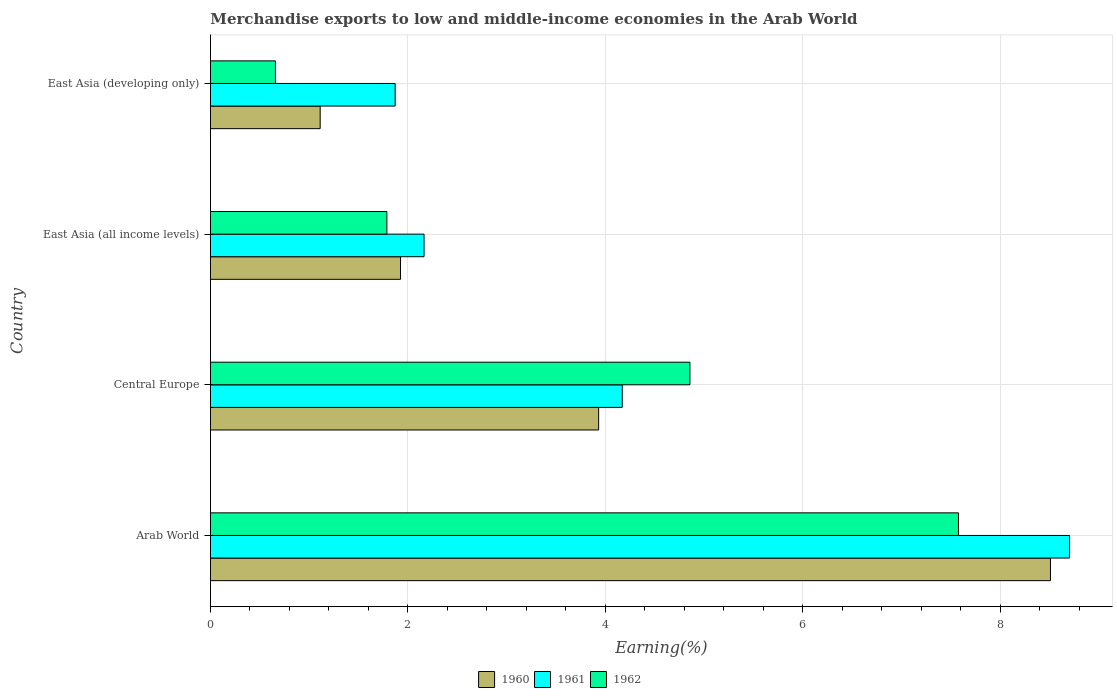How many groups of bars are there?
Your answer should be compact. 4. What is the label of the 3rd group of bars from the top?
Make the answer very short. Central Europe. In how many cases, is the number of bars for a given country not equal to the number of legend labels?
Offer a very short reply. 0. What is the percentage of amount earned from merchandise exports in 1960 in Arab World?
Keep it short and to the point. 8.51. Across all countries, what is the maximum percentage of amount earned from merchandise exports in 1960?
Keep it short and to the point. 8.51. Across all countries, what is the minimum percentage of amount earned from merchandise exports in 1960?
Offer a very short reply. 1.11. In which country was the percentage of amount earned from merchandise exports in 1961 maximum?
Provide a succinct answer. Arab World. In which country was the percentage of amount earned from merchandise exports in 1961 minimum?
Make the answer very short. East Asia (developing only). What is the total percentage of amount earned from merchandise exports in 1961 in the graph?
Offer a terse response. 16.91. What is the difference between the percentage of amount earned from merchandise exports in 1962 in Arab World and that in East Asia (developing only)?
Your answer should be compact. 6.92. What is the difference between the percentage of amount earned from merchandise exports in 1960 in Arab World and the percentage of amount earned from merchandise exports in 1961 in East Asia (developing only)?
Provide a short and direct response. 6.64. What is the average percentage of amount earned from merchandise exports in 1961 per country?
Give a very brief answer. 4.23. What is the difference between the percentage of amount earned from merchandise exports in 1960 and percentage of amount earned from merchandise exports in 1962 in East Asia (all income levels)?
Offer a terse response. 0.14. In how many countries, is the percentage of amount earned from merchandise exports in 1960 greater than 3.6 %?
Keep it short and to the point. 2. What is the ratio of the percentage of amount earned from merchandise exports in 1960 in East Asia (all income levels) to that in East Asia (developing only)?
Your answer should be very brief. 1.73. Is the difference between the percentage of amount earned from merchandise exports in 1960 in Arab World and East Asia (all income levels) greater than the difference between the percentage of amount earned from merchandise exports in 1962 in Arab World and East Asia (all income levels)?
Offer a very short reply. Yes. What is the difference between the highest and the second highest percentage of amount earned from merchandise exports in 1960?
Make the answer very short. 4.58. What is the difference between the highest and the lowest percentage of amount earned from merchandise exports in 1960?
Your response must be concise. 7.4. What does the 3rd bar from the top in Central Europe represents?
Ensure brevity in your answer.  1960. Is it the case that in every country, the sum of the percentage of amount earned from merchandise exports in 1962 and percentage of amount earned from merchandise exports in 1960 is greater than the percentage of amount earned from merchandise exports in 1961?
Provide a short and direct response. No. Are the values on the major ticks of X-axis written in scientific E-notation?
Your answer should be very brief. No. Does the graph contain grids?
Offer a terse response. Yes. What is the title of the graph?
Provide a succinct answer. Merchandise exports to low and middle-income economies in the Arab World. Does "1997" appear as one of the legend labels in the graph?
Your response must be concise. No. What is the label or title of the X-axis?
Ensure brevity in your answer.  Earning(%). What is the Earning(%) of 1960 in Arab World?
Provide a succinct answer. 8.51. What is the Earning(%) of 1961 in Arab World?
Offer a terse response. 8.7. What is the Earning(%) in 1962 in Arab World?
Keep it short and to the point. 7.58. What is the Earning(%) in 1960 in Central Europe?
Your answer should be compact. 3.93. What is the Earning(%) of 1961 in Central Europe?
Offer a terse response. 4.17. What is the Earning(%) of 1962 in Central Europe?
Make the answer very short. 4.86. What is the Earning(%) in 1960 in East Asia (all income levels)?
Your response must be concise. 1.93. What is the Earning(%) of 1961 in East Asia (all income levels)?
Keep it short and to the point. 2.16. What is the Earning(%) in 1962 in East Asia (all income levels)?
Provide a succinct answer. 1.79. What is the Earning(%) in 1960 in East Asia (developing only)?
Your response must be concise. 1.11. What is the Earning(%) of 1961 in East Asia (developing only)?
Ensure brevity in your answer.  1.87. What is the Earning(%) of 1962 in East Asia (developing only)?
Offer a terse response. 0.66. Across all countries, what is the maximum Earning(%) of 1960?
Provide a short and direct response. 8.51. Across all countries, what is the maximum Earning(%) in 1961?
Give a very brief answer. 8.7. Across all countries, what is the maximum Earning(%) of 1962?
Ensure brevity in your answer.  7.58. Across all countries, what is the minimum Earning(%) in 1960?
Provide a succinct answer. 1.11. Across all countries, what is the minimum Earning(%) of 1961?
Your answer should be very brief. 1.87. Across all countries, what is the minimum Earning(%) in 1962?
Give a very brief answer. 0.66. What is the total Earning(%) of 1960 in the graph?
Offer a terse response. 15.48. What is the total Earning(%) of 1961 in the graph?
Give a very brief answer. 16.91. What is the total Earning(%) in 1962 in the graph?
Your answer should be very brief. 14.88. What is the difference between the Earning(%) of 1960 in Arab World and that in Central Europe?
Your answer should be compact. 4.58. What is the difference between the Earning(%) in 1961 in Arab World and that in Central Europe?
Make the answer very short. 4.53. What is the difference between the Earning(%) in 1962 in Arab World and that in Central Europe?
Keep it short and to the point. 2.72. What is the difference between the Earning(%) in 1960 in Arab World and that in East Asia (all income levels)?
Offer a very short reply. 6.58. What is the difference between the Earning(%) in 1961 in Arab World and that in East Asia (all income levels)?
Keep it short and to the point. 6.54. What is the difference between the Earning(%) of 1962 in Arab World and that in East Asia (all income levels)?
Provide a short and direct response. 5.79. What is the difference between the Earning(%) in 1960 in Arab World and that in East Asia (developing only)?
Your response must be concise. 7.4. What is the difference between the Earning(%) in 1961 in Arab World and that in East Asia (developing only)?
Offer a terse response. 6.83. What is the difference between the Earning(%) of 1962 in Arab World and that in East Asia (developing only)?
Your answer should be compact. 6.92. What is the difference between the Earning(%) of 1960 in Central Europe and that in East Asia (all income levels)?
Provide a short and direct response. 2.01. What is the difference between the Earning(%) in 1961 in Central Europe and that in East Asia (all income levels)?
Your response must be concise. 2.01. What is the difference between the Earning(%) of 1962 in Central Europe and that in East Asia (all income levels)?
Keep it short and to the point. 3.07. What is the difference between the Earning(%) in 1960 in Central Europe and that in East Asia (developing only)?
Provide a short and direct response. 2.82. What is the difference between the Earning(%) in 1961 in Central Europe and that in East Asia (developing only)?
Provide a short and direct response. 2.3. What is the difference between the Earning(%) of 1962 in Central Europe and that in East Asia (developing only)?
Keep it short and to the point. 4.2. What is the difference between the Earning(%) in 1960 in East Asia (all income levels) and that in East Asia (developing only)?
Offer a very short reply. 0.81. What is the difference between the Earning(%) of 1961 in East Asia (all income levels) and that in East Asia (developing only)?
Offer a terse response. 0.29. What is the difference between the Earning(%) of 1962 in East Asia (all income levels) and that in East Asia (developing only)?
Your answer should be very brief. 1.13. What is the difference between the Earning(%) in 1960 in Arab World and the Earning(%) in 1961 in Central Europe?
Make the answer very short. 4.34. What is the difference between the Earning(%) in 1960 in Arab World and the Earning(%) in 1962 in Central Europe?
Provide a succinct answer. 3.65. What is the difference between the Earning(%) of 1961 in Arab World and the Earning(%) of 1962 in Central Europe?
Your answer should be compact. 3.85. What is the difference between the Earning(%) in 1960 in Arab World and the Earning(%) in 1961 in East Asia (all income levels)?
Your answer should be compact. 6.35. What is the difference between the Earning(%) in 1960 in Arab World and the Earning(%) in 1962 in East Asia (all income levels)?
Your response must be concise. 6.72. What is the difference between the Earning(%) in 1961 in Arab World and the Earning(%) in 1962 in East Asia (all income levels)?
Your answer should be compact. 6.92. What is the difference between the Earning(%) of 1960 in Arab World and the Earning(%) of 1961 in East Asia (developing only)?
Keep it short and to the point. 6.64. What is the difference between the Earning(%) of 1960 in Arab World and the Earning(%) of 1962 in East Asia (developing only)?
Your answer should be compact. 7.85. What is the difference between the Earning(%) of 1961 in Arab World and the Earning(%) of 1962 in East Asia (developing only)?
Ensure brevity in your answer.  8.05. What is the difference between the Earning(%) in 1960 in Central Europe and the Earning(%) in 1961 in East Asia (all income levels)?
Your answer should be compact. 1.77. What is the difference between the Earning(%) of 1960 in Central Europe and the Earning(%) of 1962 in East Asia (all income levels)?
Your answer should be very brief. 2.15. What is the difference between the Earning(%) in 1961 in Central Europe and the Earning(%) in 1962 in East Asia (all income levels)?
Your response must be concise. 2.38. What is the difference between the Earning(%) of 1960 in Central Europe and the Earning(%) of 1961 in East Asia (developing only)?
Provide a succinct answer. 2.06. What is the difference between the Earning(%) in 1960 in Central Europe and the Earning(%) in 1962 in East Asia (developing only)?
Ensure brevity in your answer.  3.27. What is the difference between the Earning(%) in 1961 in Central Europe and the Earning(%) in 1962 in East Asia (developing only)?
Your answer should be very brief. 3.51. What is the difference between the Earning(%) in 1960 in East Asia (all income levels) and the Earning(%) in 1961 in East Asia (developing only)?
Provide a succinct answer. 0.05. What is the difference between the Earning(%) of 1960 in East Asia (all income levels) and the Earning(%) of 1962 in East Asia (developing only)?
Your answer should be compact. 1.27. What is the difference between the Earning(%) of 1961 in East Asia (all income levels) and the Earning(%) of 1962 in East Asia (developing only)?
Give a very brief answer. 1.51. What is the average Earning(%) of 1960 per country?
Provide a succinct answer. 3.87. What is the average Earning(%) of 1961 per country?
Keep it short and to the point. 4.23. What is the average Earning(%) of 1962 per country?
Give a very brief answer. 3.72. What is the difference between the Earning(%) of 1960 and Earning(%) of 1961 in Arab World?
Your answer should be compact. -0.19. What is the difference between the Earning(%) of 1960 and Earning(%) of 1962 in Arab World?
Give a very brief answer. 0.93. What is the difference between the Earning(%) in 1961 and Earning(%) in 1962 in Arab World?
Provide a short and direct response. 1.13. What is the difference between the Earning(%) in 1960 and Earning(%) in 1961 in Central Europe?
Your answer should be compact. -0.24. What is the difference between the Earning(%) in 1960 and Earning(%) in 1962 in Central Europe?
Ensure brevity in your answer.  -0.92. What is the difference between the Earning(%) in 1961 and Earning(%) in 1962 in Central Europe?
Your answer should be compact. -0.69. What is the difference between the Earning(%) of 1960 and Earning(%) of 1961 in East Asia (all income levels)?
Offer a terse response. -0.24. What is the difference between the Earning(%) in 1960 and Earning(%) in 1962 in East Asia (all income levels)?
Provide a short and direct response. 0.14. What is the difference between the Earning(%) in 1961 and Earning(%) in 1962 in East Asia (all income levels)?
Offer a terse response. 0.38. What is the difference between the Earning(%) of 1960 and Earning(%) of 1961 in East Asia (developing only)?
Provide a succinct answer. -0.76. What is the difference between the Earning(%) in 1960 and Earning(%) in 1962 in East Asia (developing only)?
Give a very brief answer. 0.45. What is the difference between the Earning(%) in 1961 and Earning(%) in 1962 in East Asia (developing only)?
Your answer should be compact. 1.21. What is the ratio of the Earning(%) in 1960 in Arab World to that in Central Europe?
Provide a succinct answer. 2.16. What is the ratio of the Earning(%) of 1961 in Arab World to that in Central Europe?
Your answer should be very brief. 2.09. What is the ratio of the Earning(%) in 1962 in Arab World to that in Central Europe?
Make the answer very short. 1.56. What is the ratio of the Earning(%) in 1960 in Arab World to that in East Asia (all income levels)?
Your response must be concise. 4.42. What is the ratio of the Earning(%) of 1961 in Arab World to that in East Asia (all income levels)?
Ensure brevity in your answer.  4.02. What is the ratio of the Earning(%) of 1962 in Arab World to that in East Asia (all income levels)?
Ensure brevity in your answer.  4.24. What is the ratio of the Earning(%) of 1960 in Arab World to that in East Asia (developing only)?
Provide a succinct answer. 7.66. What is the ratio of the Earning(%) in 1961 in Arab World to that in East Asia (developing only)?
Offer a very short reply. 4.65. What is the ratio of the Earning(%) in 1962 in Arab World to that in East Asia (developing only)?
Ensure brevity in your answer.  11.51. What is the ratio of the Earning(%) of 1960 in Central Europe to that in East Asia (all income levels)?
Give a very brief answer. 2.04. What is the ratio of the Earning(%) of 1961 in Central Europe to that in East Asia (all income levels)?
Keep it short and to the point. 1.93. What is the ratio of the Earning(%) of 1962 in Central Europe to that in East Asia (all income levels)?
Offer a terse response. 2.72. What is the ratio of the Earning(%) in 1960 in Central Europe to that in East Asia (developing only)?
Make the answer very short. 3.54. What is the ratio of the Earning(%) of 1961 in Central Europe to that in East Asia (developing only)?
Provide a short and direct response. 2.23. What is the ratio of the Earning(%) in 1962 in Central Europe to that in East Asia (developing only)?
Ensure brevity in your answer.  7.38. What is the ratio of the Earning(%) of 1960 in East Asia (all income levels) to that in East Asia (developing only)?
Keep it short and to the point. 1.73. What is the ratio of the Earning(%) in 1961 in East Asia (all income levels) to that in East Asia (developing only)?
Provide a short and direct response. 1.16. What is the ratio of the Earning(%) in 1962 in East Asia (all income levels) to that in East Asia (developing only)?
Provide a short and direct response. 2.72. What is the difference between the highest and the second highest Earning(%) of 1960?
Your answer should be compact. 4.58. What is the difference between the highest and the second highest Earning(%) in 1961?
Make the answer very short. 4.53. What is the difference between the highest and the second highest Earning(%) in 1962?
Your answer should be compact. 2.72. What is the difference between the highest and the lowest Earning(%) of 1960?
Your answer should be compact. 7.4. What is the difference between the highest and the lowest Earning(%) of 1961?
Ensure brevity in your answer.  6.83. What is the difference between the highest and the lowest Earning(%) of 1962?
Keep it short and to the point. 6.92. 